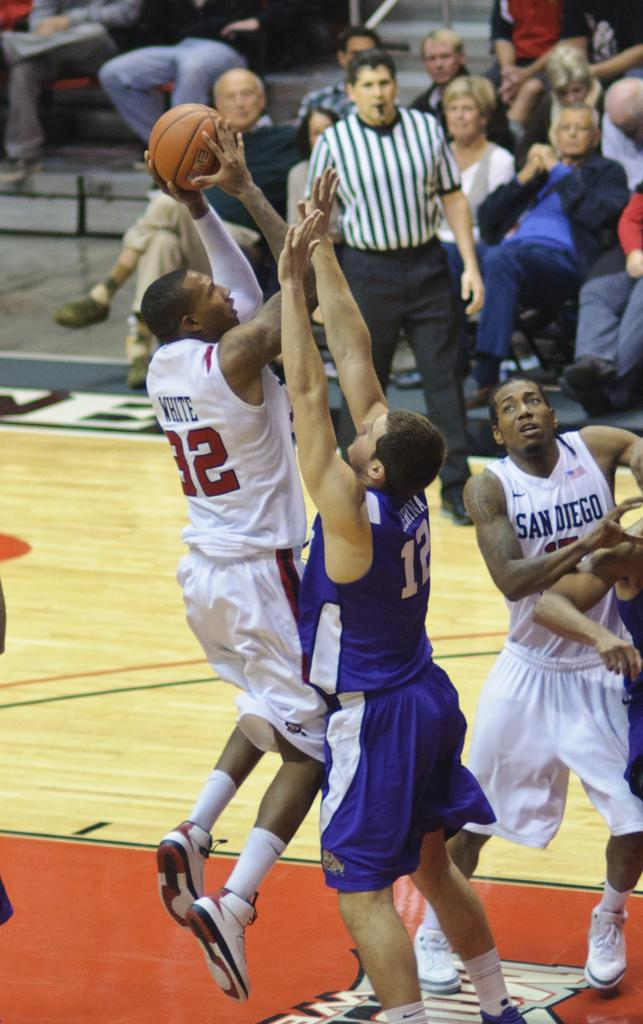What activity are the people in the image engaged in? There is a group of people playing basketball in the image. Can you describe the position of the person standing in the image? There is a person standing in the image, but their position cannot be determined from the provided facts. What are the people in the background doing? In the background, there is a group of people sitting. What shape is the rake used by the person in the image? There is no rake present in the image. Can you describe the contents of the drawer in the image? There is no drawer present in the image. 